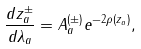Convert formula to latex. <formula><loc_0><loc_0><loc_500><loc_500>\frac { d z _ { a } ^ { \pm } } { d \lambda _ { a } } = A _ { a } ^ { ( \pm ) } e ^ { - 2 \rho ( z _ { a } ) } ,</formula> 